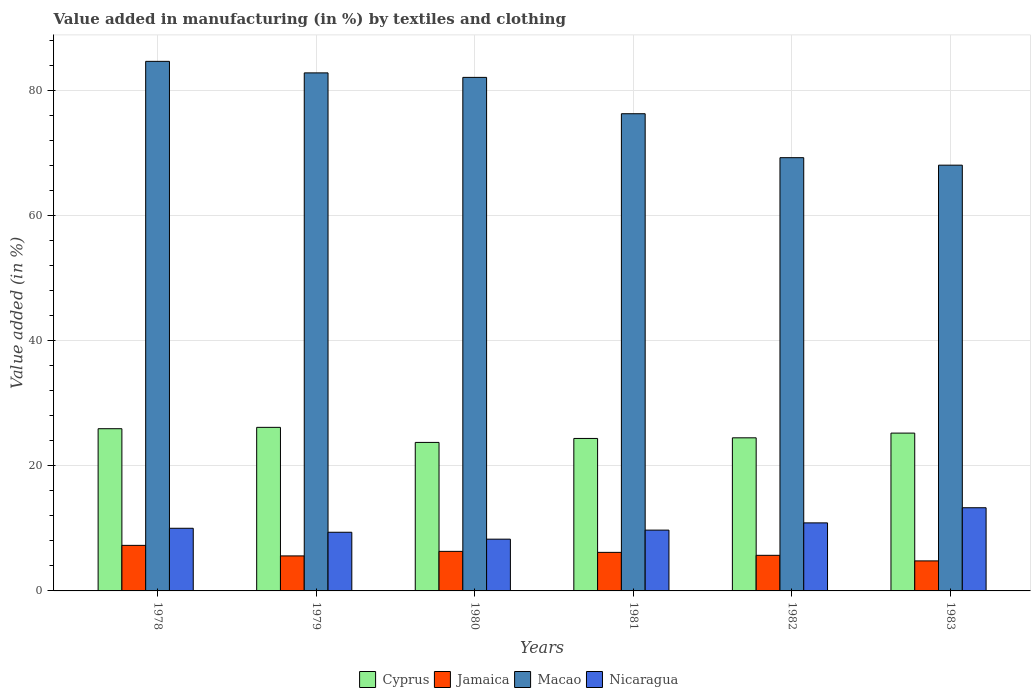What is the label of the 6th group of bars from the left?
Provide a short and direct response. 1983. What is the percentage of value added in manufacturing by textiles and clothing in Jamaica in 1979?
Keep it short and to the point. 5.59. Across all years, what is the maximum percentage of value added in manufacturing by textiles and clothing in Jamaica?
Offer a very short reply. 7.28. Across all years, what is the minimum percentage of value added in manufacturing by textiles and clothing in Jamaica?
Your answer should be compact. 4.8. In which year was the percentage of value added in manufacturing by textiles and clothing in Macao maximum?
Offer a terse response. 1978. What is the total percentage of value added in manufacturing by textiles and clothing in Macao in the graph?
Provide a short and direct response. 462.83. What is the difference between the percentage of value added in manufacturing by textiles and clothing in Nicaragua in 1979 and that in 1981?
Your answer should be very brief. -0.34. What is the difference between the percentage of value added in manufacturing by textiles and clothing in Jamaica in 1978 and the percentage of value added in manufacturing by textiles and clothing in Cyprus in 1980?
Your answer should be compact. -16.44. What is the average percentage of value added in manufacturing by textiles and clothing in Macao per year?
Keep it short and to the point. 77.14. In the year 1979, what is the difference between the percentage of value added in manufacturing by textiles and clothing in Jamaica and percentage of value added in manufacturing by textiles and clothing in Cyprus?
Your answer should be compact. -20.54. What is the ratio of the percentage of value added in manufacturing by textiles and clothing in Nicaragua in 1979 to that in 1982?
Ensure brevity in your answer.  0.86. What is the difference between the highest and the second highest percentage of value added in manufacturing by textiles and clothing in Nicaragua?
Your answer should be very brief. 2.42. What is the difference between the highest and the lowest percentage of value added in manufacturing by textiles and clothing in Jamaica?
Keep it short and to the point. 2.48. Is it the case that in every year, the sum of the percentage of value added in manufacturing by textiles and clothing in Macao and percentage of value added in manufacturing by textiles and clothing in Nicaragua is greater than the sum of percentage of value added in manufacturing by textiles and clothing in Cyprus and percentage of value added in manufacturing by textiles and clothing in Jamaica?
Offer a terse response. Yes. What does the 1st bar from the left in 1978 represents?
Keep it short and to the point. Cyprus. What does the 1st bar from the right in 1978 represents?
Ensure brevity in your answer.  Nicaragua. Are all the bars in the graph horizontal?
Keep it short and to the point. No. How many years are there in the graph?
Offer a terse response. 6. What is the difference between two consecutive major ticks on the Y-axis?
Your answer should be compact. 20. Are the values on the major ticks of Y-axis written in scientific E-notation?
Offer a terse response. No. Does the graph contain any zero values?
Your response must be concise. No. Where does the legend appear in the graph?
Your response must be concise. Bottom center. What is the title of the graph?
Keep it short and to the point. Value added in manufacturing (in %) by textiles and clothing. What is the label or title of the X-axis?
Offer a very short reply. Years. What is the label or title of the Y-axis?
Provide a succinct answer. Value added (in %). What is the Value added (in %) in Cyprus in 1978?
Your response must be concise. 25.91. What is the Value added (in %) of Jamaica in 1978?
Provide a short and direct response. 7.28. What is the Value added (in %) of Macao in 1978?
Ensure brevity in your answer.  84.59. What is the Value added (in %) in Nicaragua in 1978?
Provide a succinct answer. 10.01. What is the Value added (in %) in Cyprus in 1979?
Make the answer very short. 26.13. What is the Value added (in %) in Jamaica in 1979?
Your response must be concise. 5.59. What is the Value added (in %) of Macao in 1979?
Provide a succinct answer. 82.75. What is the Value added (in %) of Nicaragua in 1979?
Your response must be concise. 9.37. What is the Value added (in %) of Cyprus in 1980?
Ensure brevity in your answer.  23.72. What is the Value added (in %) in Jamaica in 1980?
Provide a succinct answer. 6.32. What is the Value added (in %) of Macao in 1980?
Offer a terse response. 82.03. What is the Value added (in %) of Nicaragua in 1980?
Give a very brief answer. 8.27. What is the Value added (in %) of Cyprus in 1981?
Your answer should be compact. 24.36. What is the Value added (in %) of Jamaica in 1981?
Your response must be concise. 6.16. What is the Value added (in %) of Macao in 1981?
Give a very brief answer. 76.23. What is the Value added (in %) in Nicaragua in 1981?
Ensure brevity in your answer.  9.71. What is the Value added (in %) of Cyprus in 1982?
Make the answer very short. 24.46. What is the Value added (in %) of Jamaica in 1982?
Make the answer very short. 5.69. What is the Value added (in %) of Macao in 1982?
Provide a succinct answer. 69.21. What is the Value added (in %) of Nicaragua in 1982?
Make the answer very short. 10.87. What is the Value added (in %) of Cyprus in 1983?
Offer a terse response. 25.21. What is the Value added (in %) in Jamaica in 1983?
Keep it short and to the point. 4.8. What is the Value added (in %) of Macao in 1983?
Ensure brevity in your answer.  68.01. What is the Value added (in %) in Nicaragua in 1983?
Make the answer very short. 13.29. Across all years, what is the maximum Value added (in %) in Cyprus?
Your answer should be compact. 26.13. Across all years, what is the maximum Value added (in %) in Jamaica?
Provide a succinct answer. 7.28. Across all years, what is the maximum Value added (in %) of Macao?
Provide a succinct answer. 84.59. Across all years, what is the maximum Value added (in %) in Nicaragua?
Provide a succinct answer. 13.29. Across all years, what is the minimum Value added (in %) of Cyprus?
Ensure brevity in your answer.  23.72. Across all years, what is the minimum Value added (in %) in Jamaica?
Make the answer very short. 4.8. Across all years, what is the minimum Value added (in %) in Macao?
Offer a terse response. 68.01. Across all years, what is the minimum Value added (in %) in Nicaragua?
Your answer should be very brief. 8.27. What is the total Value added (in %) of Cyprus in the graph?
Make the answer very short. 149.79. What is the total Value added (in %) in Jamaica in the graph?
Ensure brevity in your answer.  35.83. What is the total Value added (in %) of Macao in the graph?
Offer a terse response. 462.83. What is the total Value added (in %) in Nicaragua in the graph?
Make the answer very short. 61.52. What is the difference between the Value added (in %) of Cyprus in 1978 and that in 1979?
Your answer should be very brief. -0.22. What is the difference between the Value added (in %) of Jamaica in 1978 and that in 1979?
Make the answer very short. 1.69. What is the difference between the Value added (in %) in Macao in 1978 and that in 1979?
Provide a short and direct response. 1.84. What is the difference between the Value added (in %) in Nicaragua in 1978 and that in 1979?
Your answer should be compact. 0.64. What is the difference between the Value added (in %) of Cyprus in 1978 and that in 1980?
Ensure brevity in your answer.  2.19. What is the difference between the Value added (in %) in Jamaica in 1978 and that in 1980?
Offer a very short reply. 0.96. What is the difference between the Value added (in %) in Macao in 1978 and that in 1980?
Offer a terse response. 2.56. What is the difference between the Value added (in %) of Nicaragua in 1978 and that in 1980?
Give a very brief answer. 1.74. What is the difference between the Value added (in %) of Cyprus in 1978 and that in 1981?
Your answer should be compact. 1.55. What is the difference between the Value added (in %) of Jamaica in 1978 and that in 1981?
Your response must be concise. 1.12. What is the difference between the Value added (in %) in Macao in 1978 and that in 1981?
Your answer should be compact. 8.37. What is the difference between the Value added (in %) in Nicaragua in 1978 and that in 1981?
Your answer should be very brief. 0.29. What is the difference between the Value added (in %) of Cyprus in 1978 and that in 1982?
Offer a terse response. 1.45. What is the difference between the Value added (in %) in Jamaica in 1978 and that in 1982?
Your response must be concise. 1.59. What is the difference between the Value added (in %) in Macao in 1978 and that in 1982?
Make the answer very short. 15.39. What is the difference between the Value added (in %) of Nicaragua in 1978 and that in 1982?
Your answer should be very brief. -0.86. What is the difference between the Value added (in %) in Cyprus in 1978 and that in 1983?
Provide a short and direct response. 0.7. What is the difference between the Value added (in %) of Jamaica in 1978 and that in 1983?
Provide a short and direct response. 2.48. What is the difference between the Value added (in %) of Macao in 1978 and that in 1983?
Your answer should be compact. 16.58. What is the difference between the Value added (in %) in Nicaragua in 1978 and that in 1983?
Give a very brief answer. -3.28. What is the difference between the Value added (in %) in Cyprus in 1979 and that in 1980?
Your answer should be compact. 2.41. What is the difference between the Value added (in %) in Jamaica in 1979 and that in 1980?
Make the answer very short. -0.73. What is the difference between the Value added (in %) of Macao in 1979 and that in 1980?
Give a very brief answer. 0.72. What is the difference between the Value added (in %) of Nicaragua in 1979 and that in 1980?
Keep it short and to the point. 1.1. What is the difference between the Value added (in %) in Cyprus in 1979 and that in 1981?
Make the answer very short. 1.77. What is the difference between the Value added (in %) in Jamaica in 1979 and that in 1981?
Provide a succinct answer. -0.57. What is the difference between the Value added (in %) of Macao in 1979 and that in 1981?
Your response must be concise. 6.53. What is the difference between the Value added (in %) of Nicaragua in 1979 and that in 1981?
Your response must be concise. -0.34. What is the difference between the Value added (in %) in Cyprus in 1979 and that in 1982?
Provide a short and direct response. 1.67. What is the difference between the Value added (in %) of Jamaica in 1979 and that in 1982?
Give a very brief answer. -0.1. What is the difference between the Value added (in %) in Macao in 1979 and that in 1982?
Offer a terse response. 13.54. What is the difference between the Value added (in %) of Nicaragua in 1979 and that in 1982?
Ensure brevity in your answer.  -1.5. What is the difference between the Value added (in %) in Cyprus in 1979 and that in 1983?
Offer a terse response. 0.92. What is the difference between the Value added (in %) of Jamaica in 1979 and that in 1983?
Provide a succinct answer. 0.8. What is the difference between the Value added (in %) in Macao in 1979 and that in 1983?
Offer a terse response. 14.74. What is the difference between the Value added (in %) in Nicaragua in 1979 and that in 1983?
Give a very brief answer. -3.92. What is the difference between the Value added (in %) in Cyprus in 1980 and that in 1981?
Give a very brief answer. -0.64. What is the difference between the Value added (in %) of Jamaica in 1980 and that in 1981?
Offer a terse response. 0.16. What is the difference between the Value added (in %) in Macao in 1980 and that in 1981?
Offer a very short reply. 5.81. What is the difference between the Value added (in %) of Nicaragua in 1980 and that in 1981?
Your answer should be very brief. -1.45. What is the difference between the Value added (in %) of Cyprus in 1980 and that in 1982?
Provide a short and direct response. -0.74. What is the difference between the Value added (in %) in Jamaica in 1980 and that in 1982?
Give a very brief answer. 0.63. What is the difference between the Value added (in %) of Macao in 1980 and that in 1982?
Your answer should be compact. 12.83. What is the difference between the Value added (in %) of Nicaragua in 1980 and that in 1982?
Provide a succinct answer. -2.6. What is the difference between the Value added (in %) in Cyprus in 1980 and that in 1983?
Your answer should be very brief. -1.49. What is the difference between the Value added (in %) of Jamaica in 1980 and that in 1983?
Offer a terse response. 1.52. What is the difference between the Value added (in %) in Macao in 1980 and that in 1983?
Ensure brevity in your answer.  14.02. What is the difference between the Value added (in %) in Nicaragua in 1980 and that in 1983?
Give a very brief answer. -5.02. What is the difference between the Value added (in %) in Cyprus in 1981 and that in 1982?
Give a very brief answer. -0.1. What is the difference between the Value added (in %) in Jamaica in 1981 and that in 1982?
Ensure brevity in your answer.  0.47. What is the difference between the Value added (in %) of Macao in 1981 and that in 1982?
Your answer should be compact. 7.02. What is the difference between the Value added (in %) of Nicaragua in 1981 and that in 1982?
Provide a short and direct response. -1.16. What is the difference between the Value added (in %) in Cyprus in 1981 and that in 1983?
Offer a terse response. -0.85. What is the difference between the Value added (in %) in Jamaica in 1981 and that in 1983?
Offer a very short reply. 1.36. What is the difference between the Value added (in %) in Macao in 1981 and that in 1983?
Your answer should be compact. 8.22. What is the difference between the Value added (in %) in Nicaragua in 1981 and that in 1983?
Ensure brevity in your answer.  -3.57. What is the difference between the Value added (in %) in Cyprus in 1982 and that in 1983?
Your answer should be very brief. -0.75. What is the difference between the Value added (in %) in Jamaica in 1982 and that in 1983?
Provide a succinct answer. 0.89. What is the difference between the Value added (in %) in Macao in 1982 and that in 1983?
Provide a succinct answer. 1.2. What is the difference between the Value added (in %) of Nicaragua in 1982 and that in 1983?
Offer a terse response. -2.42. What is the difference between the Value added (in %) in Cyprus in 1978 and the Value added (in %) in Jamaica in 1979?
Offer a terse response. 20.32. What is the difference between the Value added (in %) of Cyprus in 1978 and the Value added (in %) of Macao in 1979?
Provide a short and direct response. -56.84. What is the difference between the Value added (in %) of Cyprus in 1978 and the Value added (in %) of Nicaragua in 1979?
Ensure brevity in your answer.  16.54. What is the difference between the Value added (in %) in Jamaica in 1978 and the Value added (in %) in Macao in 1979?
Keep it short and to the point. -75.47. What is the difference between the Value added (in %) in Jamaica in 1978 and the Value added (in %) in Nicaragua in 1979?
Offer a very short reply. -2.09. What is the difference between the Value added (in %) in Macao in 1978 and the Value added (in %) in Nicaragua in 1979?
Your answer should be very brief. 75.22. What is the difference between the Value added (in %) in Cyprus in 1978 and the Value added (in %) in Jamaica in 1980?
Your answer should be compact. 19.59. What is the difference between the Value added (in %) in Cyprus in 1978 and the Value added (in %) in Macao in 1980?
Keep it short and to the point. -56.12. What is the difference between the Value added (in %) in Cyprus in 1978 and the Value added (in %) in Nicaragua in 1980?
Provide a succinct answer. 17.64. What is the difference between the Value added (in %) of Jamaica in 1978 and the Value added (in %) of Macao in 1980?
Offer a very short reply. -74.76. What is the difference between the Value added (in %) in Jamaica in 1978 and the Value added (in %) in Nicaragua in 1980?
Your answer should be very brief. -0.99. What is the difference between the Value added (in %) in Macao in 1978 and the Value added (in %) in Nicaragua in 1980?
Offer a terse response. 76.33. What is the difference between the Value added (in %) of Cyprus in 1978 and the Value added (in %) of Jamaica in 1981?
Give a very brief answer. 19.75. What is the difference between the Value added (in %) of Cyprus in 1978 and the Value added (in %) of Macao in 1981?
Give a very brief answer. -50.32. What is the difference between the Value added (in %) of Cyprus in 1978 and the Value added (in %) of Nicaragua in 1981?
Your response must be concise. 16.2. What is the difference between the Value added (in %) of Jamaica in 1978 and the Value added (in %) of Macao in 1981?
Offer a terse response. -68.95. What is the difference between the Value added (in %) in Jamaica in 1978 and the Value added (in %) in Nicaragua in 1981?
Give a very brief answer. -2.44. What is the difference between the Value added (in %) of Macao in 1978 and the Value added (in %) of Nicaragua in 1981?
Give a very brief answer. 74.88. What is the difference between the Value added (in %) of Cyprus in 1978 and the Value added (in %) of Jamaica in 1982?
Offer a terse response. 20.22. What is the difference between the Value added (in %) of Cyprus in 1978 and the Value added (in %) of Macao in 1982?
Your answer should be compact. -43.3. What is the difference between the Value added (in %) of Cyprus in 1978 and the Value added (in %) of Nicaragua in 1982?
Your response must be concise. 15.04. What is the difference between the Value added (in %) in Jamaica in 1978 and the Value added (in %) in Macao in 1982?
Give a very brief answer. -61.93. What is the difference between the Value added (in %) in Jamaica in 1978 and the Value added (in %) in Nicaragua in 1982?
Provide a succinct answer. -3.59. What is the difference between the Value added (in %) in Macao in 1978 and the Value added (in %) in Nicaragua in 1982?
Your response must be concise. 73.72. What is the difference between the Value added (in %) in Cyprus in 1978 and the Value added (in %) in Jamaica in 1983?
Keep it short and to the point. 21.11. What is the difference between the Value added (in %) of Cyprus in 1978 and the Value added (in %) of Macao in 1983?
Offer a terse response. -42.1. What is the difference between the Value added (in %) of Cyprus in 1978 and the Value added (in %) of Nicaragua in 1983?
Keep it short and to the point. 12.62. What is the difference between the Value added (in %) in Jamaica in 1978 and the Value added (in %) in Macao in 1983?
Provide a succinct answer. -60.73. What is the difference between the Value added (in %) of Jamaica in 1978 and the Value added (in %) of Nicaragua in 1983?
Ensure brevity in your answer.  -6.01. What is the difference between the Value added (in %) of Macao in 1978 and the Value added (in %) of Nicaragua in 1983?
Give a very brief answer. 71.31. What is the difference between the Value added (in %) of Cyprus in 1979 and the Value added (in %) of Jamaica in 1980?
Your answer should be compact. 19.81. What is the difference between the Value added (in %) of Cyprus in 1979 and the Value added (in %) of Macao in 1980?
Your answer should be very brief. -55.91. What is the difference between the Value added (in %) in Cyprus in 1979 and the Value added (in %) in Nicaragua in 1980?
Provide a short and direct response. 17.86. What is the difference between the Value added (in %) of Jamaica in 1979 and the Value added (in %) of Macao in 1980?
Keep it short and to the point. -76.44. What is the difference between the Value added (in %) in Jamaica in 1979 and the Value added (in %) in Nicaragua in 1980?
Keep it short and to the point. -2.68. What is the difference between the Value added (in %) of Macao in 1979 and the Value added (in %) of Nicaragua in 1980?
Ensure brevity in your answer.  74.48. What is the difference between the Value added (in %) of Cyprus in 1979 and the Value added (in %) of Jamaica in 1981?
Your answer should be compact. 19.97. What is the difference between the Value added (in %) in Cyprus in 1979 and the Value added (in %) in Macao in 1981?
Your answer should be very brief. -50.1. What is the difference between the Value added (in %) of Cyprus in 1979 and the Value added (in %) of Nicaragua in 1981?
Keep it short and to the point. 16.42. What is the difference between the Value added (in %) in Jamaica in 1979 and the Value added (in %) in Macao in 1981?
Ensure brevity in your answer.  -70.63. What is the difference between the Value added (in %) of Jamaica in 1979 and the Value added (in %) of Nicaragua in 1981?
Provide a succinct answer. -4.12. What is the difference between the Value added (in %) of Macao in 1979 and the Value added (in %) of Nicaragua in 1981?
Provide a short and direct response. 73.04. What is the difference between the Value added (in %) of Cyprus in 1979 and the Value added (in %) of Jamaica in 1982?
Ensure brevity in your answer.  20.44. What is the difference between the Value added (in %) of Cyprus in 1979 and the Value added (in %) of Macao in 1982?
Your answer should be compact. -43.08. What is the difference between the Value added (in %) in Cyprus in 1979 and the Value added (in %) in Nicaragua in 1982?
Your answer should be compact. 15.26. What is the difference between the Value added (in %) in Jamaica in 1979 and the Value added (in %) in Macao in 1982?
Your response must be concise. -63.62. What is the difference between the Value added (in %) of Jamaica in 1979 and the Value added (in %) of Nicaragua in 1982?
Your answer should be very brief. -5.28. What is the difference between the Value added (in %) of Macao in 1979 and the Value added (in %) of Nicaragua in 1982?
Your answer should be compact. 71.88. What is the difference between the Value added (in %) of Cyprus in 1979 and the Value added (in %) of Jamaica in 1983?
Provide a succinct answer. 21.33. What is the difference between the Value added (in %) in Cyprus in 1979 and the Value added (in %) in Macao in 1983?
Ensure brevity in your answer.  -41.88. What is the difference between the Value added (in %) of Cyprus in 1979 and the Value added (in %) of Nicaragua in 1983?
Provide a short and direct response. 12.84. What is the difference between the Value added (in %) of Jamaica in 1979 and the Value added (in %) of Macao in 1983?
Ensure brevity in your answer.  -62.42. What is the difference between the Value added (in %) of Jamaica in 1979 and the Value added (in %) of Nicaragua in 1983?
Your response must be concise. -7.7. What is the difference between the Value added (in %) in Macao in 1979 and the Value added (in %) in Nicaragua in 1983?
Your answer should be compact. 69.46. What is the difference between the Value added (in %) of Cyprus in 1980 and the Value added (in %) of Jamaica in 1981?
Offer a very short reply. 17.56. What is the difference between the Value added (in %) of Cyprus in 1980 and the Value added (in %) of Macao in 1981?
Your answer should be compact. -52.51. What is the difference between the Value added (in %) in Cyprus in 1980 and the Value added (in %) in Nicaragua in 1981?
Give a very brief answer. 14.01. What is the difference between the Value added (in %) in Jamaica in 1980 and the Value added (in %) in Macao in 1981?
Provide a short and direct response. -69.91. What is the difference between the Value added (in %) in Jamaica in 1980 and the Value added (in %) in Nicaragua in 1981?
Your response must be concise. -3.4. What is the difference between the Value added (in %) in Macao in 1980 and the Value added (in %) in Nicaragua in 1981?
Give a very brief answer. 72.32. What is the difference between the Value added (in %) in Cyprus in 1980 and the Value added (in %) in Jamaica in 1982?
Your answer should be very brief. 18.03. What is the difference between the Value added (in %) in Cyprus in 1980 and the Value added (in %) in Macao in 1982?
Your answer should be very brief. -45.49. What is the difference between the Value added (in %) in Cyprus in 1980 and the Value added (in %) in Nicaragua in 1982?
Your answer should be very brief. 12.85. What is the difference between the Value added (in %) in Jamaica in 1980 and the Value added (in %) in Macao in 1982?
Offer a terse response. -62.89. What is the difference between the Value added (in %) in Jamaica in 1980 and the Value added (in %) in Nicaragua in 1982?
Your answer should be compact. -4.55. What is the difference between the Value added (in %) of Macao in 1980 and the Value added (in %) of Nicaragua in 1982?
Offer a terse response. 71.17. What is the difference between the Value added (in %) of Cyprus in 1980 and the Value added (in %) of Jamaica in 1983?
Offer a very short reply. 18.93. What is the difference between the Value added (in %) in Cyprus in 1980 and the Value added (in %) in Macao in 1983?
Provide a short and direct response. -44.29. What is the difference between the Value added (in %) in Cyprus in 1980 and the Value added (in %) in Nicaragua in 1983?
Your response must be concise. 10.43. What is the difference between the Value added (in %) of Jamaica in 1980 and the Value added (in %) of Macao in 1983?
Give a very brief answer. -61.69. What is the difference between the Value added (in %) of Jamaica in 1980 and the Value added (in %) of Nicaragua in 1983?
Your answer should be very brief. -6.97. What is the difference between the Value added (in %) of Macao in 1980 and the Value added (in %) of Nicaragua in 1983?
Provide a short and direct response. 68.75. What is the difference between the Value added (in %) of Cyprus in 1981 and the Value added (in %) of Jamaica in 1982?
Ensure brevity in your answer.  18.67. What is the difference between the Value added (in %) of Cyprus in 1981 and the Value added (in %) of Macao in 1982?
Provide a short and direct response. -44.85. What is the difference between the Value added (in %) of Cyprus in 1981 and the Value added (in %) of Nicaragua in 1982?
Keep it short and to the point. 13.49. What is the difference between the Value added (in %) of Jamaica in 1981 and the Value added (in %) of Macao in 1982?
Keep it short and to the point. -63.05. What is the difference between the Value added (in %) of Jamaica in 1981 and the Value added (in %) of Nicaragua in 1982?
Provide a succinct answer. -4.71. What is the difference between the Value added (in %) of Macao in 1981 and the Value added (in %) of Nicaragua in 1982?
Offer a very short reply. 65.36. What is the difference between the Value added (in %) in Cyprus in 1981 and the Value added (in %) in Jamaica in 1983?
Offer a very short reply. 19.56. What is the difference between the Value added (in %) in Cyprus in 1981 and the Value added (in %) in Macao in 1983?
Your answer should be compact. -43.65. What is the difference between the Value added (in %) of Cyprus in 1981 and the Value added (in %) of Nicaragua in 1983?
Provide a succinct answer. 11.07. What is the difference between the Value added (in %) in Jamaica in 1981 and the Value added (in %) in Macao in 1983?
Give a very brief answer. -61.85. What is the difference between the Value added (in %) of Jamaica in 1981 and the Value added (in %) of Nicaragua in 1983?
Provide a succinct answer. -7.13. What is the difference between the Value added (in %) in Macao in 1981 and the Value added (in %) in Nicaragua in 1983?
Offer a very short reply. 62.94. What is the difference between the Value added (in %) of Cyprus in 1982 and the Value added (in %) of Jamaica in 1983?
Ensure brevity in your answer.  19.66. What is the difference between the Value added (in %) in Cyprus in 1982 and the Value added (in %) in Macao in 1983?
Provide a succinct answer. -43.55. What is the difference between the Value added (in %) in Cyprus in 1982 and the Value added (in %) in Nicaragua in 1983?
Offer a terse response. 11.17. What is the difference between the Value added (in %) in Jamaica in 1982 and the Value added (in %) in Macao in 1983?
Provide a short and direct response. -62.32. What is the difference between the Value added (in %) in Jamaica in 1982 and the Value added (in %) in Nicaragua in 1983?
Provide a succinct answer. -7.6. What is the difference between the Value added (in %) in Macao in 1982 and the Value added (in %) in Nicaragua in 1983?
Provide a short and direct response. 55.92. What is the average Value added (in %) of Cyprus per year?
Your answer should be very brief. 24.96. What is the average Value added (in %) in Jamaica per year?
Offer a very short reply. 5.97. What is the average Value added (in %) in Macao per year?
Your response must be concise. 77.14. What is the average Value added (in %) in Nicaragua per year?
Provide a short and direct response. 10.25. In the year 1978, what is the difference between the Value added (in %) of Cyprus and Value added (in %) of Jamaica?
Your response must be concise. 18.63. In the year 1978, what is the difference between the Value added (in %) of Cyprus and Value added (in %) of Macao?
Provide a succinct answer. -58.68. In the year 1978, what is the difference between the Value added (in %) in Cyprus and Value added (in %) in Nicaragua?
Give a very brief answer. 15.91. In the year 1978, what is the difference between the Value added (in %) in Jamaica and Value added (in %) in Macao?
Make the answer very short. -77.32. In the year 1978, what is the difference between the Value added (in %) in Jamaica and Value added (in %) in Nicaragua?
Provide a succinct answer. -2.73. In the year 1978, what is the difference between the Value added (in %) of Macao and Value added (in %) of Nicaragua?
Offer a very short reply. 74.59. In the year 1979, what is the difference between the Value added (in %) in Cyprus and Value added (in %) in Jamaica?
Provide a succinct answer. 20.54. In the year 1979, what is the difference between the Value added (in %) in Cyprus and Value added (in %) in Macao?
Provide a short and direct response. -56.62. In the year 1979, what is the difference between the Value added (in %) in Cyprus and Value added (in %) in Nicaragua?
Your answer should be very brief. 16.76. In the year 1979, what is the difference between the Value added (in %) in Jamaica and Value added (in %) in Macao?
Make the answer very short. -77.16. In the year 1979, what is the difference between the Value added (in %) of Jamaica and Value added (in %) of Nicaragua?
Keep it short and to the point. -3.78. In the year 1979, what is the difference between the Value added (in %) of Macao and Value added (in %) of Nicaragua?
Your response must be concise. 73.38. In the year 1980, what is the difference between the Value added (in %) of Cyprus and Value added (in %) of Jamaica?
Your answer should be very brief. 17.4. In the year 1980, what is the difference between the Value added (in %) of Cyprus and Value added (in %) of Macao?
Ensure brevity in your answer.  -58.31. In the year 1980, what is the difference between the Value added (in %) in Cyprus and Value added (in %) in Nicaragua?
Ensure brevity in your answer.  15.45. In the year 1980, what is the difference between the Value added (in %) of Jamaica and Value added (in %) of Macao?
Your answer should be compact. -75.72. In the year 1980, what is the difference between the Value added (in %) in Jamaica and Value added (in %) in Nicaragua?
Your response must be concise. -1.95. In the year 1980, what is the difference between the Value added (in %) in Macao and Value added (in %) in Nicaragua?
Keep it short and to the point. 73.77. In the year 1981, what is the difference between the Value added (in %) in Cyprus and Value added (in %) in Jamaica?
Your answer should be compact. 18.2. In the year 1981, what is the difference between the Value added (in %) in Cyprus and Value added (in %) in Macao?
Offer a very short reply. -51.87. In the year 1981, what is the difference between the Value added (in %) in Cyprus and Value added (in %) in Nicaragua?
Provide a succinct answer. 14.64. In the year 1981, what is the difference between the Value added (in %) of Jamaica and Value added (in %) of Macao?
Your answer should be very brief. -70.07. In the year 1981, what is the difference between the Value added (in %) of Jamaica and Value added (in %) of Nicaragua?
Your answer should be compact. -3.55. In the year 1981, what is the difference between the Value added (in %) of Macao and Value added (in %) of Nicaragua?
Keep it short and to the point. 66.51. In the year 1982, what is the difference between the Value added (in %) in Cyprus and Value added (in %) in Jamaica?
Make the answer very short. 18.77. In the year 1982, what is the difference between the Value added (in %) of Cyprus and Value added (in %) of Macao?
Offer a terse response. -44.75. In the year 1982, what is the difference between the Value added (in %) of Cyprus and Value added (in %) of Nicaragua?
Provide a succinct answer. 13.59. In the year 1982, what is the difference between the Value added (in %) in Jamaica and Value added (in %) in Macao?
Make the answer very short. -63.52. In the year 1982, what is the difference between the Value added (in %) of Jamaica and Value added (in %) of Nicaragua?
Ensure brevity in your answer.  -5.18. In the year 1982, what is the difference between the Value added (in %) of Macao and Value added (in %) of Nicaragua?
Offer a very short reply. 58.34. In the year 1983, what is the difference between the Value added (in %) in Cyprus and Value added (in %) in Jamaica?
Make the answer very short. 20.41. In the year 1983, what is the difference between the Value added (in %) of Cyprus and Value added (in %) of Macao?
Give a very brief answer. -42.8. In the year 1983, what is the difference between the Value added (in %) of Cyprus and Value added (in %) of Nicaragua?
Your response must be concise. 11.92. In the year 1983, what is the difference between the Value added (in %) of Jamaica and Value added (in %) of Macao?
Your response must be concise. -63.21. In the year 1983, what is the difference between the Value added (in %) of Jamaica and Value added (in %) of Nicaragua?
Your answer should be very brief. -8.49. In the year 1983, what is the difference between the Value added (in %) of Macao and Value added (in %) of Nicaragua?
Give a very brief answer. 54.72. What is the ratio of the Value added (in %) of Cyprus in 1978 to that in 1979?
Offer a terse response. 0.99. What is the ratio of the Value added (in %) of Jamaica in 1978 to that in 1979?
Your answer should be very brief. 1.3. What is the ratio of the Value added (in %) in Macao in 1978 to that in 1979?
Provide a short and direct response. 1.02. What is the ratio of the Value added (in %) in Nicaragua in 1978 to that in 1979?
Your answer should be compact. 1.07. What is the ratio of the Value added (in %) in Cyprus in 1978 to that in 1980?
Give a very brief answer. 1.09. What is the ratio of the Value added (in %) in Jamaica in 1978 to that in 1980?
Provide a short and direct response. 1.15. What is the ratio of the Value added (in %) of Macao in 1978 to that in 1980?
Provide a succinct answer. 1.03. What is the ratio of the Value added (in %) in Nicaragua in 1978 to that in 1980?
Your answer should be very brief. 1.21. What is the ratio of the Value added (in %) in Cyprus in 1978 to that in 1981?
Offer a very short reply. 1.06. What is the ratio of the Value added (in %) in Jamaica in 1978 to that in 1981?
Keep it short and to the point. 1.18. What is the ratio of the Value added (in %) in Macao in 1978 to that in 1981?
Keep it short and to the point. 1.11. What is the ratio of the Value added (in %) of Nicaragua in 1978 to that in 1981?
Offer a terse response. 1.03. What is the ratio of the Value added (in %) in Cyprus in 1978 to that in 1982?
Offer a terse response. 1.06. What is the ratio of the Value added (in %) of Jamaica in 1978 to that in 1982?
Keep it short and to the point. 1.28. What is the ratio of the Value added (in %) in Macao in 1978 to that in 1982?
Keep it short and to the point. 1.22. What is the ratio of the Value added (in %) in Nicaragua in 1978 to that in 1982?
Give a very brief answer. 0.92. What is the ratio of the Value added (in %) of Cyprus in 1978 to that in 1983?
Your answer should be very brief. 1.03. What is the ratio of the Value added (in %) of Jamaica in 1978 to that in 1983?
Ensure brevity in your answer.  1.52. What is the ratio of the Value added (in %) of Macao in 1978 to that in 1983?
Offer a very short reply. 1.24. What is the ratio of the Value added (in %) in Nicaragua in 1978 to that in 1983?
Your answer should be very brief. 0.75. What is the ratio of the Value added (in %) of Cyprus in 1979 to that in 1980?
Offer a terse response. 1.1. What is the ratio of the Value added (in %) of Jamaica in 1979 to that in 1980?
Give a very brief answer. 0.89. What is the ratio of the Value added (in %) in Macao in 1979 to that in 1980?
Your answer should be compact. 1.01. What is the ratio of the Value added (in %) in Nicaragua in 1979 to that in 1980?
Your answer should be very brief. 1.13. What is the ratio of the Value added (in %) of Cyprus in 1979 to that in 1981?
Your answer should be compact. 1.07. What is the ratio of the Value added (in %) of Jamaica in 1979 to that in 1981?
Give a very brief answer. 0.91. What is the ratio of the Value added (in %) in Macao in 1979 to that in 1981?
Ensure brevity in your answer.  1.09. What is the ratio of the Value added (in %) of Nicaragua in 1979 to that in 1981?
Provide a succinct answer. 0.96. What is the ratio of the Value added (in %) of Cyprus in 1979 to that in 1982?
Offer a very short reply. 1.07. What is the ratio of the Value added (in %) of Jamaica in 1979 to that in 1982?
Make the answer very short. 0.98. What is the ratio of the Value added (in %) of Macao in 1979 to that in 1982?
Your answer should be compact. 1.2. What is the ratio of the Value added (in %) of Nicaragua in 1979 to that in 1982?
Give a very brief answer. 0.86. What is the ratio of the Value added (in %) in Cyprus in 1979 to that in 1983?
Provide a short and direct response. 1.04. What is the ratio of the Value added (in %) in Jamaica in 1979 to that in 1983?
Your answer should be very brief. 1.17. What is the ratio of the Value added (in %) of Macao in 1979 to that in 1983?
Your response must be concise. 1.22. What is the ratio of the Value added (in %) in Nicaragua in 1979 to that in 1983?
Your answer should be compact. 0.71. What is the ratio of the Value added (in %) in Cyprus in 1980 to that in 1981?
Keep it short and to the point. 0.97. What is the ratio of the Value added (in %) of Jamaica in 1980 to that in 1981?
Provide a short and direct response. 1.03. What is the ratio of the Value added (in %) in Macao in 1980 to that in 1981?
Offer a very short reply. 1.08. What is the ratio of the Value added (in %) in Nicaragua in 1980 to that in 1981?
Ensure brevity in your answer.  0.85. What is the ratio of the Value added (in %) in Cyprus in 1980 to that in 1982?
Offer a very short reply. 0.97. What is the ratio of the Value added (in %) of Jamaica in 1980 to that in 1982?
Your answer should be compact. 1.11. What is the ratio of the Value added (in %) in Macao in 1980 to that in 1982?
Give a very brief answer. 1.19. What is the ratio of the Value added (in %) in Nicaragua in 1980 to that in 1982?
Your answer should be compact. 0.76. What is the ratio of the Value added (in %) in Cyprus in 1980 to that in 1983?
Keep it short and to the point. 0.94. What is the ratio of the Value added (in %) in Jamaica in 1980 to that in 1983?
Offer a terse response. 1.32. What is the ratio of the Value added (in %) in Macao in 1980 to that in 1983?
Ensure brevity in your answer.  1.21. What is the ratio of the Value added (in %) in Nicaragua in 1980 to that in 1983?
Your answer should be very brief. 0.62. What is the ratio of the Value added (in %) in Cyprus in 1981 to that in 1982?
Offer a very short reply. 1. What is the ratio of the Value added (in %) of Jamaica in 1981 to that in 1982?
Provide a succinct answer. 1.08. What is the ratio of the Value added (in %) of Macao in 1981 to that in 1982?
Make the answer very short. 1.1. What is the ratio of the Value added (in %) of Nicaragua in 1981 to that in 1982?
Make the answer very short. 0.89. What is the ratio of the Value added (in %) in Cyprus in 1981 to that in 1983?
Offer a very short reply. 0.97. What is the ratio of the Value added (in %) in Jamaica in 1981 to that in 1983?
Give a very brief answer. 1.28. What is the ratio of the Value added (in %) in Macao in 1981 to that in 1983?
Your answer should be compact. 1.12. What is the ratio of the Value added (in %) in Nicaragua in 1981 to that in 1983?
Your response must be concise. 0.73. What is the ratio of the Value added (in %) of Cyprus in 1982 to that in 1983?
Keep it short and to the point. 0.97. What is the ratio of the Value added (in %) of Jamaica in 1982 to that in 1983?
Your response must be concise. 1.19. What is the ratio of the Value added (in %) in Macao in 1982 to that in 1983?
Make the answer very short. 1.02. What is the ratio of the Value added (in %) in Nicaragua in 1982 to that in 1983?
Your response must be concise. 0.82. What is the difference between the highest and the second highest Value added (in %) in Cyprus?
Offer a very short reply. 0.22. What is the difference between the highest and the second highest Value added (in %) in Jamaica?
Keep it short and to the point. 0.96. What is the difference between the highest and the second highest Value added (in %) in Macao?
Provide a short and direct response. 1.84. What is the difference between the highest and the second highest Value added (in %) in Nicaragua?
Provide a short and direct response. 2.42. What is the difference between the highest and the lowest Value added (in %) of Cyprus?
Give a very brief answer. 2.41. What is the difference between the highest and the lowest Value added (in %) in Jamaica?
Your answer should be compact. 2.48. What is the difference between the highest and the lowest Value added (in %) of Macao?
Ensure brevity in your answer.  16.58. What is the difference between the highest and the lowest Value added (in %) in Nicaragua?
Provide a succinct answer. 5.02. 